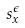Convert formula to latex. <formula><loc_0><loc_0><loc_500><loc_500>s _ { x } ^ { \epsilon }</formula> 